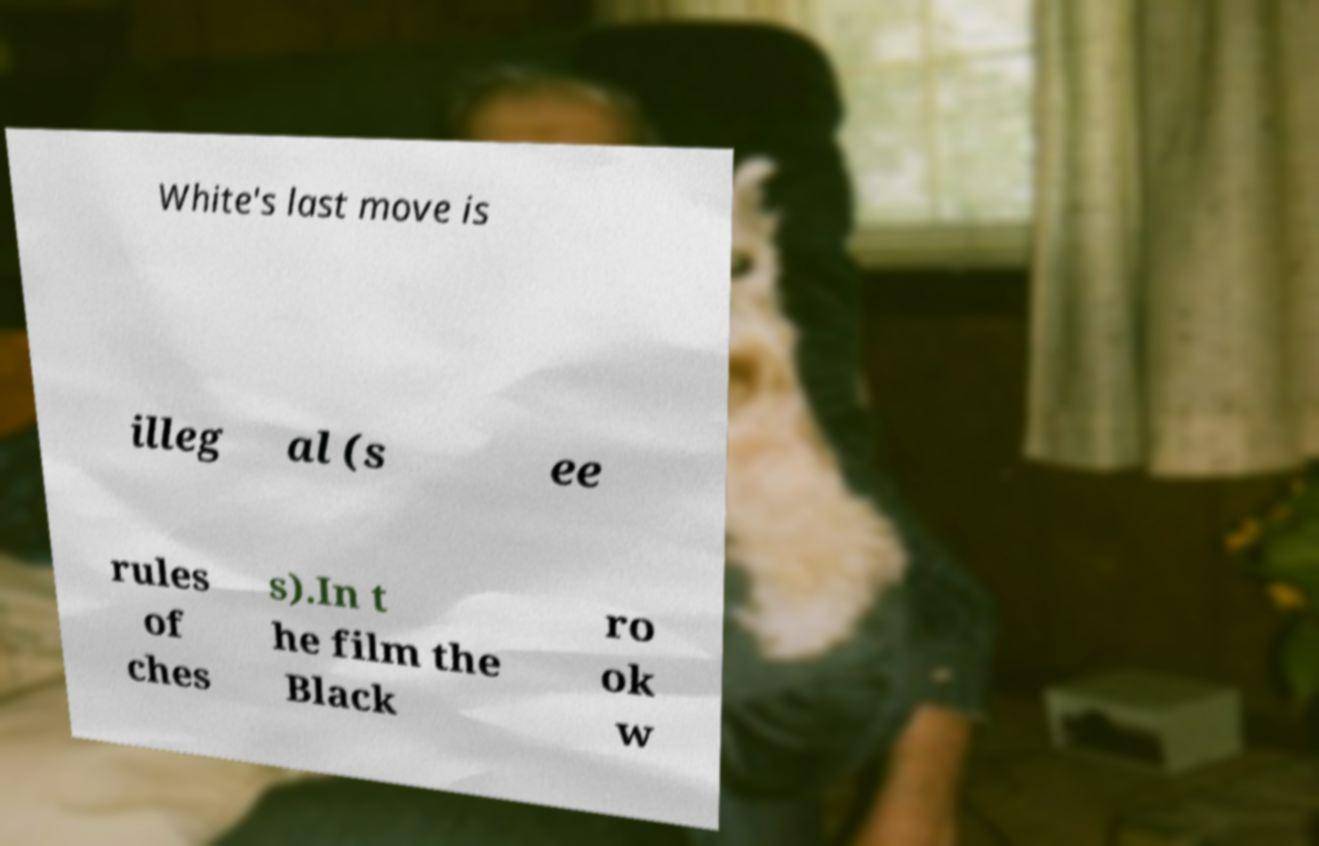For documentation purposes, I need the text within this image transcribed. Could you provide that? White's last move is illeg al (s ee rules of ches s).In t he film the Black ro ok w 